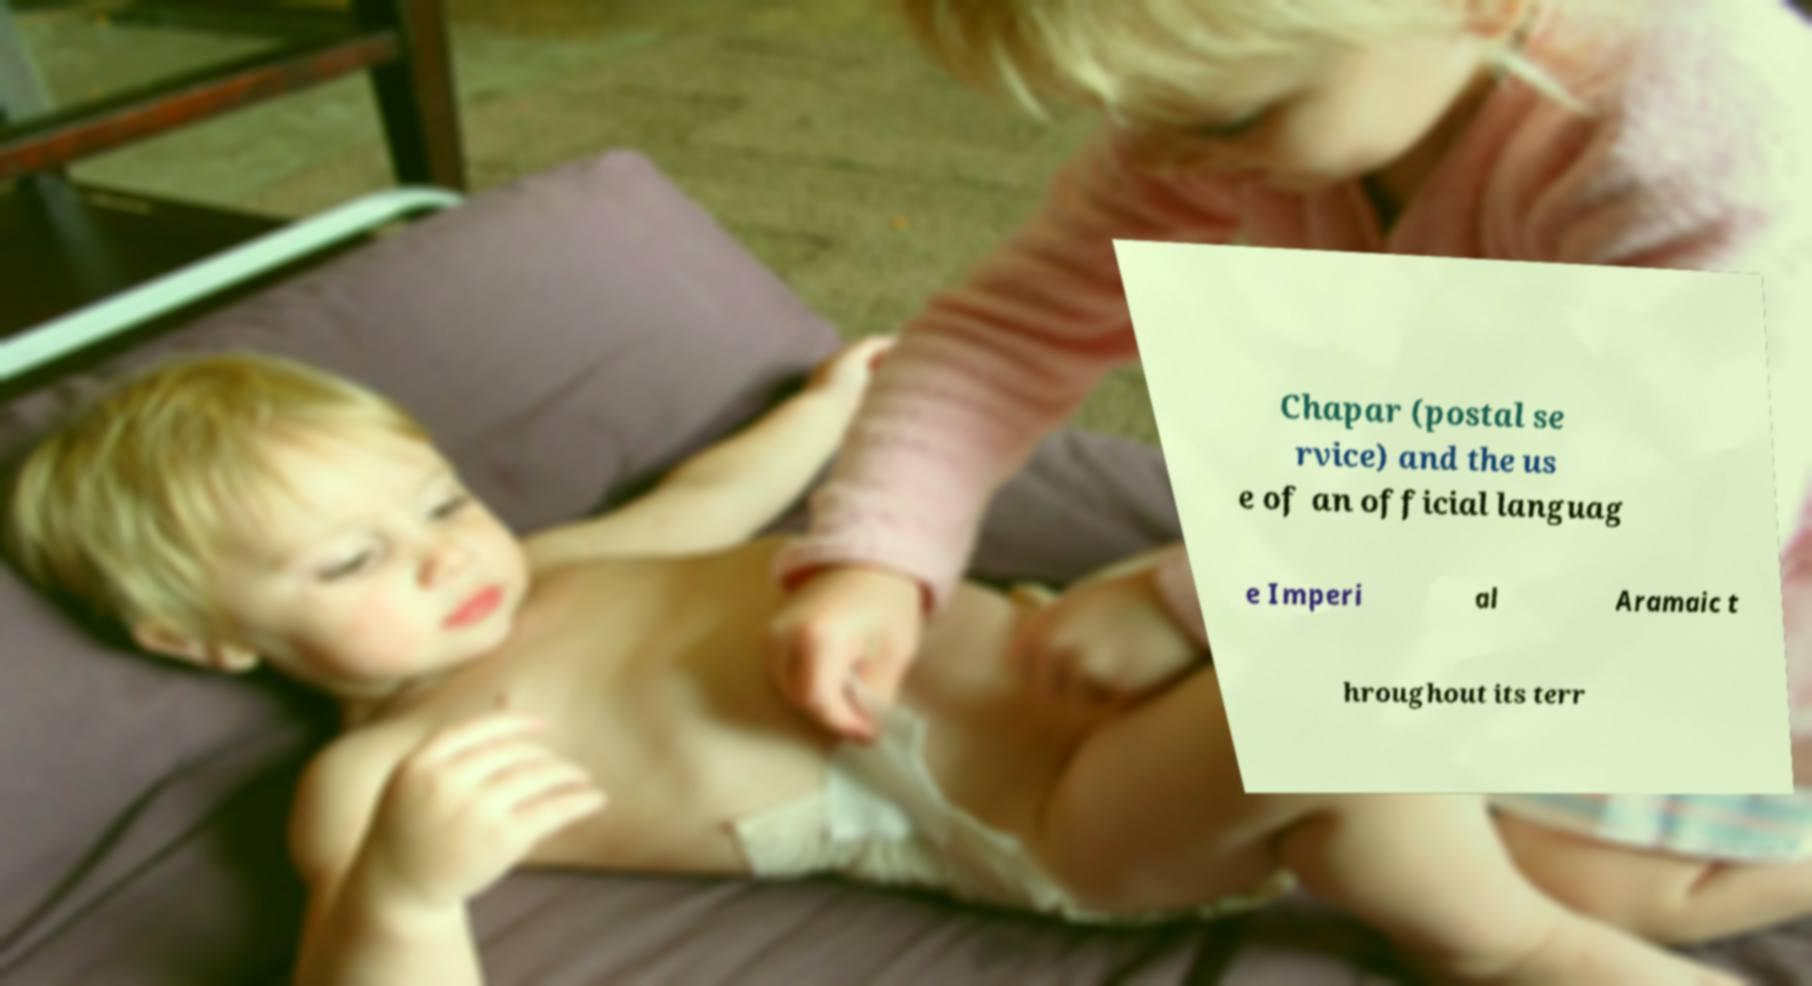What messages or text are displayed in this image? I need them in a readable, typed format. Chapar (postal se rvice) and the us e of an official languag e Imperi al Aramaic t hroughout its terr 